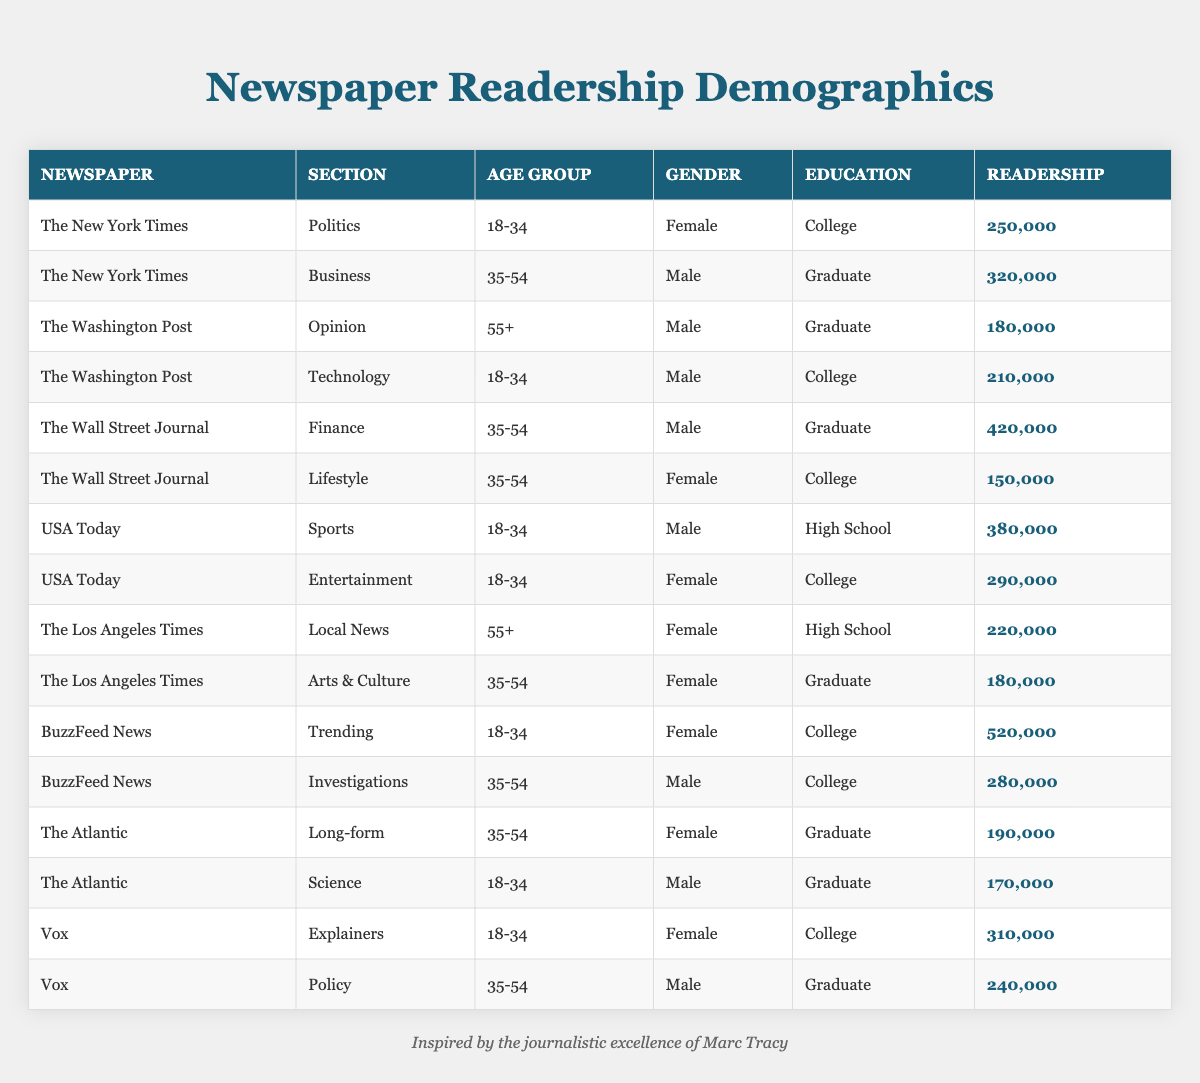What is the readership of the Politics section in The New York Times? The table shows the readership for each section. I look at the row for The New York Times in the Politics section, which lists a readership of 250,000.
Answer: 250,000 Which newspaper has the largest readership in the Business section? I find the readership numbers for the Business section in the relevant rows. The Wall Street Journal is not included, while The New York Times has 320,000. This is the highest for the Business section.
Answer: The New York Times How many readers are female in the 35-54 age group across all newspapers? I look for rows in the 35-54 age group and filter for females, which includes sections from The Wall Street Journal (150,000), The Atlantic (190,000), and BuzzFeed News (280,000). I sum these values: 150,000 + 190,000 + 280,000 = 620,000.
Answer: 620,000 Is the readership for the Opinion section in The Washington Post more than 200,000? The table shows the readership for the Opinion section in The Washington Post is 180,000. Since this is less than 200,000, the answer is no.
Answer: No What is the total readership for all articles targeting the 18-34 age group? I identify all rows targeting the 18-34 age group and their readerships: The New York Times (250,000), USA Today (380,000), BuzzFeed News (520,000), The Atlantic (170,000), and Vox (310,000). I sum these values: 250,000 + 380,000 + 520,000 + 170,000 + 310,000 = 1,630,000.
Answer: 1,630,000 Are there any male readers in the Sports section of USA Today? In the table, the Sports section of USA Today shows a readership of 380,000 and lists the gender as Male since it appears in the row provided. Thus, the assertion is true.
Answer: Yes What is the average readership for female readers in the 18-34 age group? I collect all rows indicating female readers in the 18-34 age group: The New York Times (250,000), USA Today (290,000), BuzzFeed News (520,000), and Vox (310,000). The total is 250,000 + 290,000 + 520,000 + 310,000 = 1,370,000. There are four data points, so the average is 1,370,000 / 4 = 342,500.
Answer: 342,500 Which paper has more articles with female readers in the 55+ age group? I review the table for female readership in the 55+ age group: The Los Angeles Times (220,000) and The Washington Post (180,000). Comparing these, The Los Angeles Times has more.
Answer: The Los Angeles Times How many total people read the Technology section across the newspapers? I find the readership for Technology sections in the table. The Washington Post has 210,000, and there are no other records for Technology across the other papers. So, total readership equals 210,000.
Answer: 210,000 